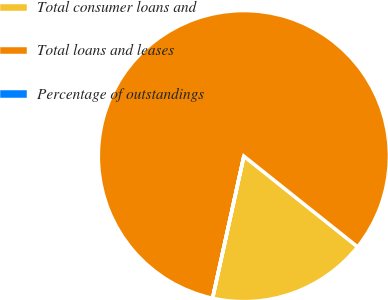<chart> <loc_0><loc_0><loc_500><loc_500><pie_chart><fcel>Total consumer loans and<fcel>Total loans and leases<fcel>Percentage of outstandings<nl><fcel>17.73%<fcel>82.26%<fcel>0.01%<nl></chart> 